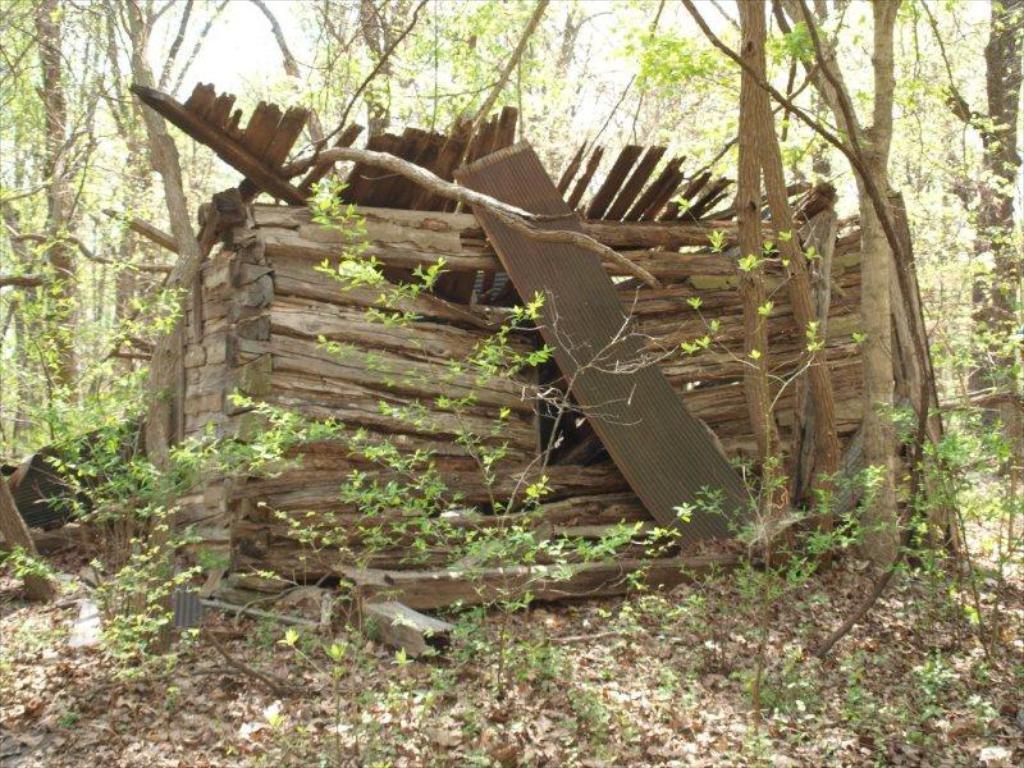Could you give a brief overview of what you see in this image? In the center of the image we can see group of wood logs, metal sheet and some plants. In the background, we can see a group of trees and sky. 